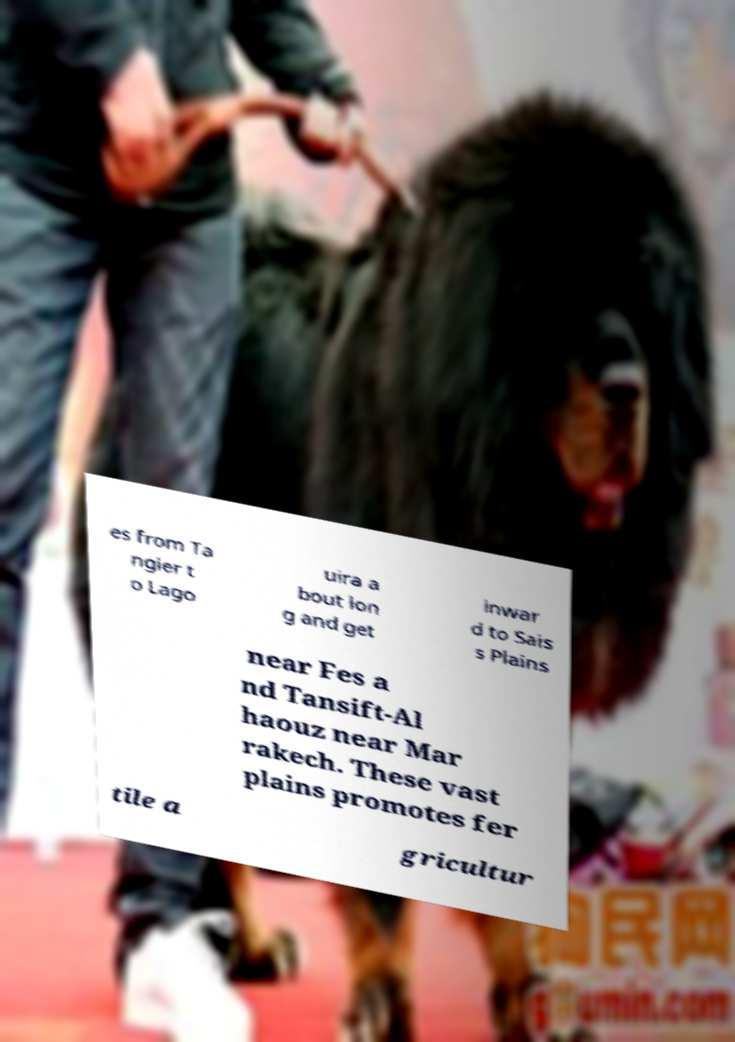Please read and relay the text visible in this image. What does it say? es from Ta ngier t o Lago uira a bout lon g and get inwar d to Sais s Plains near Fes a nd Tansift-Al haouz near Mar rakech. These vast plains promotes fer tile a gricultur 